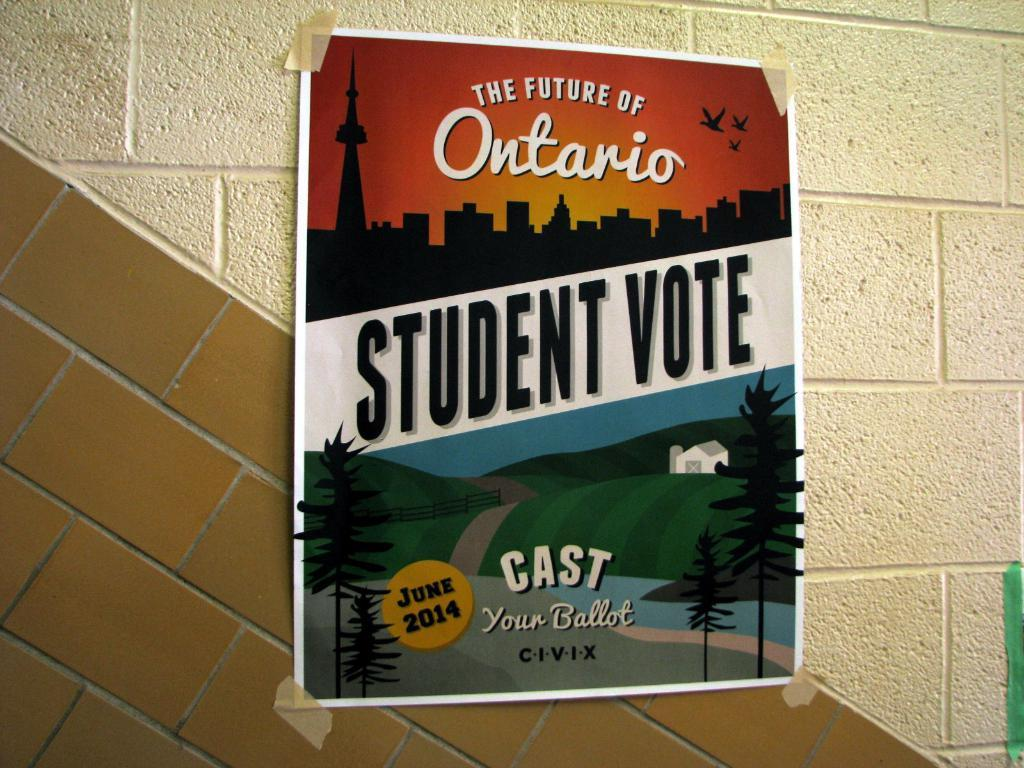<image>
Provide a brief description of the given image. A flyer encouraging student to vote for the future of Ontario. 